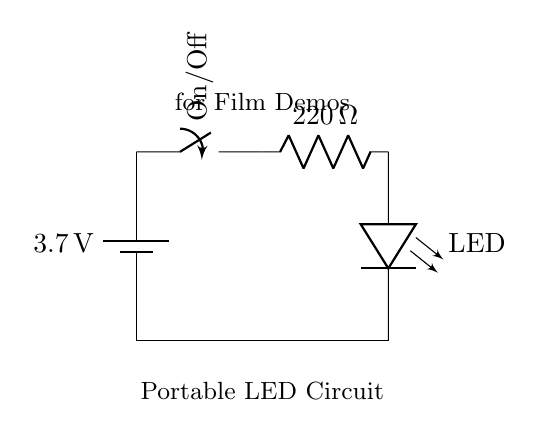What is the voltage of this circuit? The voltage is 3.7 volts, which is indicated on the battery symbol in the circuit diagram. The battery provides the power to the circuit.
Answer: 3.7 volts What is the resistance value used in the circuit? The resistance is 220 ohms, which is labeled next to the resistor in the circuit diagram. Resistors limit the current flowing through the circuit.
Answer: 220 ohms How many LEDs are present in the circuit? There is one LED, as indicated by the LED symbol in the circuit diagram. The LED is the light-emitting component in this circuit design.
Answer: One What component controls the power flow in the circuit? The component that controls power flow is the switch. It is placed in series with the battery and allows the user to turn the circuit on or off.
Answer: Switch When the switch is off, what happens to the current in the circuit? When the switch is off, the circuit is open, which means that there is no current flowing through the circuit. This interruption in the path prevents any devices from being powered.
Answer: No current What happens to the LED when the switch is turned on? When the switch is turned on, the circuit completes, allowing current to flow through to the LED, causing it to illuminate as it receives power.
Answer: LED illuminates What type of circuit is this? This is a simple series circuit. In series circuits, components are connected end-to-end, so the same current flows through each component sequentially.
Answer: Series circuit 